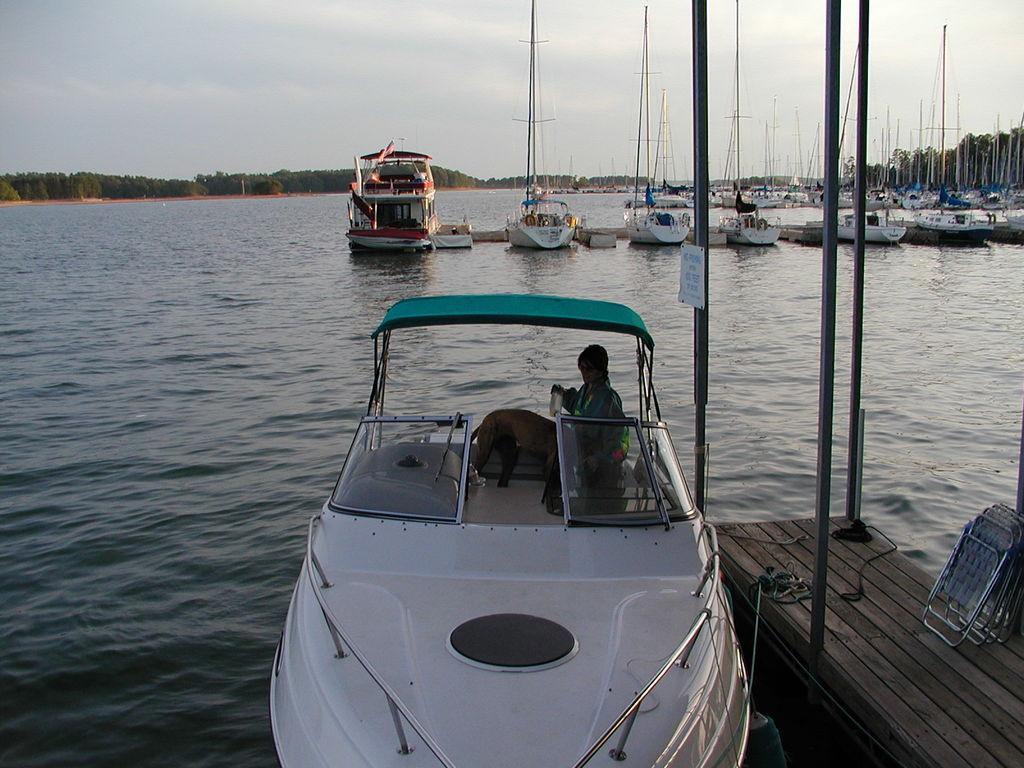In one or two sentences, can you explain what this image depicts? In this image, I can see the boats on the water. There is a woman and an animal in a boat. At the bottom right side of the image, I can see poles, ropes and foldable chairs on a wooden pathway. In the background, there are trees and the sky. 